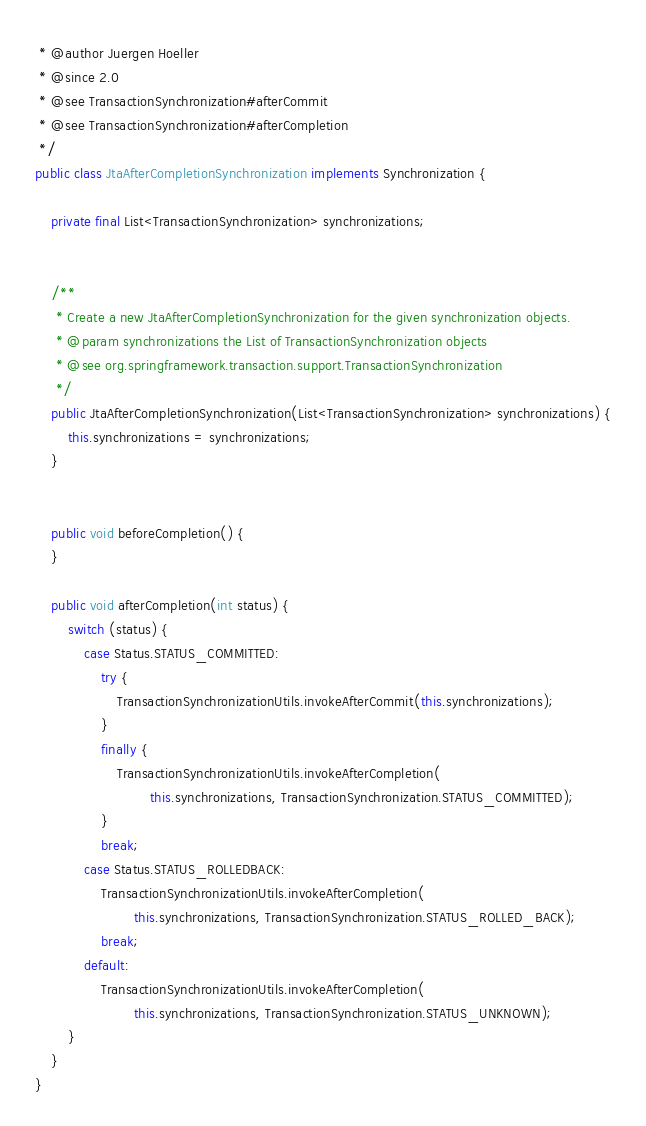Convert code to text. <code><loc_0><loc_0><loc_500><loc_500><_Java_> * @author Juergen Hoeller
 * @since 2.0
 * @see TransactionSynchronization#afterCommit
 * @see TransactionSynchronization#afterCompletion
 */
public class JtaAfterCompletionSynchronization implements Synchronization {

	private final List<TransactionSynchronization> synchronizations;


	/**
	 * Create a new JtaAfterCompletionSynchronization for the given synchronization objects.
	 * @param synchronizations the List of TransactionSynchronization objects
	 * @see org.springframework.transaction.support.TransactionSynchronization
	 */
	public JtaAfterCompletionSynchronization(List<TransactionSynchronization> synchronizations) {
		this.synchronizations = synchronizations;
	}


	public void beforeCompletion() {
	}

	public void afterCompletion(int status) {
		switch (status) {
			case Status.STATUS_COMMITTED:
				try {
					TransactionSynchronizationUtils.invokeAfterCommit(this.synchronizations);
				}
				finally {
					TransactionSynchronizationUtils.invokeAfterCompletion(
							this.synchronizations, TransactionSynchronization.STATUS_COMMITTED);
				}
				break;
			case Status.STATUS_ROLLEDBACK:
				TransactionSynchronizationUtils.invokeAfterCompletion(
						this.synchronizations, TransactionSynchronization.STATUS_ROLLED_BACK);
				break;
			default:
				TransactionSynchronizationUtils.invokeAfterCompletion(
						this.synchronizations, TransactionSynchronization.STATUS_UNKNOWN);
		}
	}
}
</code> 